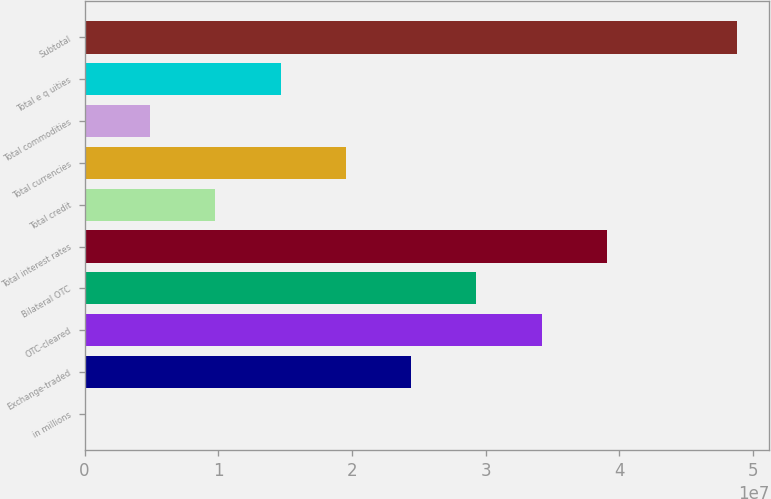Convert chart. <chart><loc_0><loc_0><loc_500><loc_500><bar_chart><fcel>in millions<fcel>Exchange-traded<fcel>OTC-cleared<fcel>Bilateral OTC<fcel>Total interest rates<fcel>Total credit<fcel>Total currencies<fcel>Total commodities<fcel>Total e q uities<fcel>Subtotal<nl><fcel>2017<fcel>2.44337e+07<fcel>3.42063e+07<fcel>2.932e+07<fcel>3.90927e+07<fcel>9.77468e+06<fcel>1.95473e+07<fcel>4.88835e+06<fcel>1.4661e+07<fcel>4.87868e+07<nl></chart> 